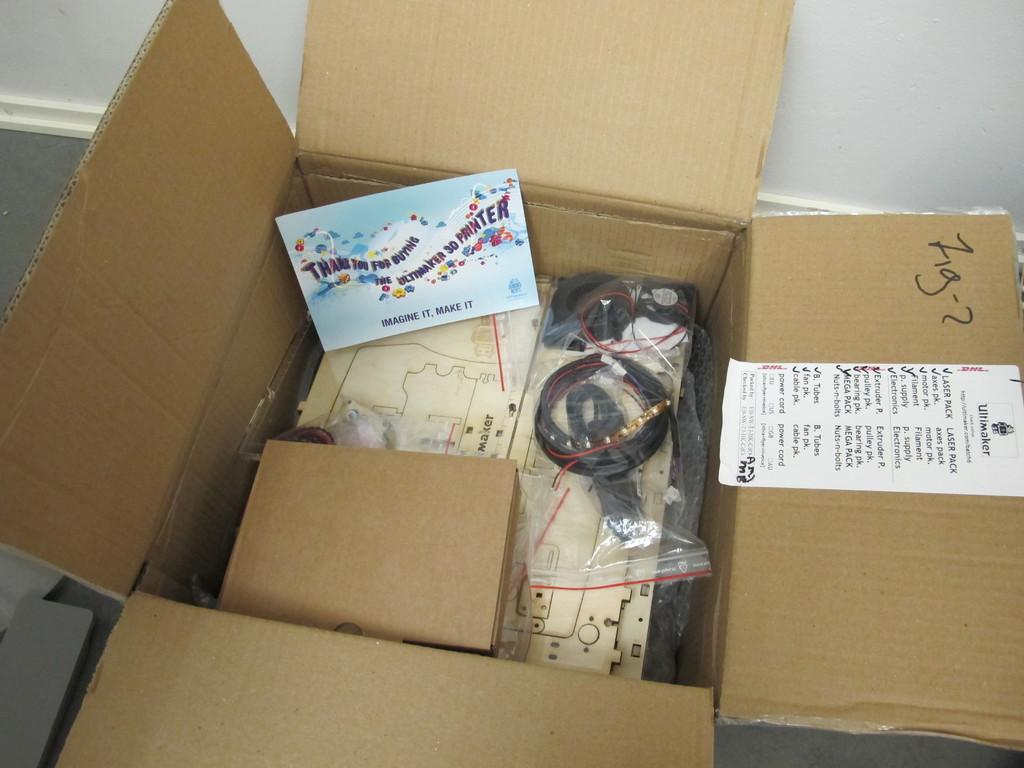<image>
Provide a brief description of the given image. The shipment of the contents of this box are from Wiltmaker. 